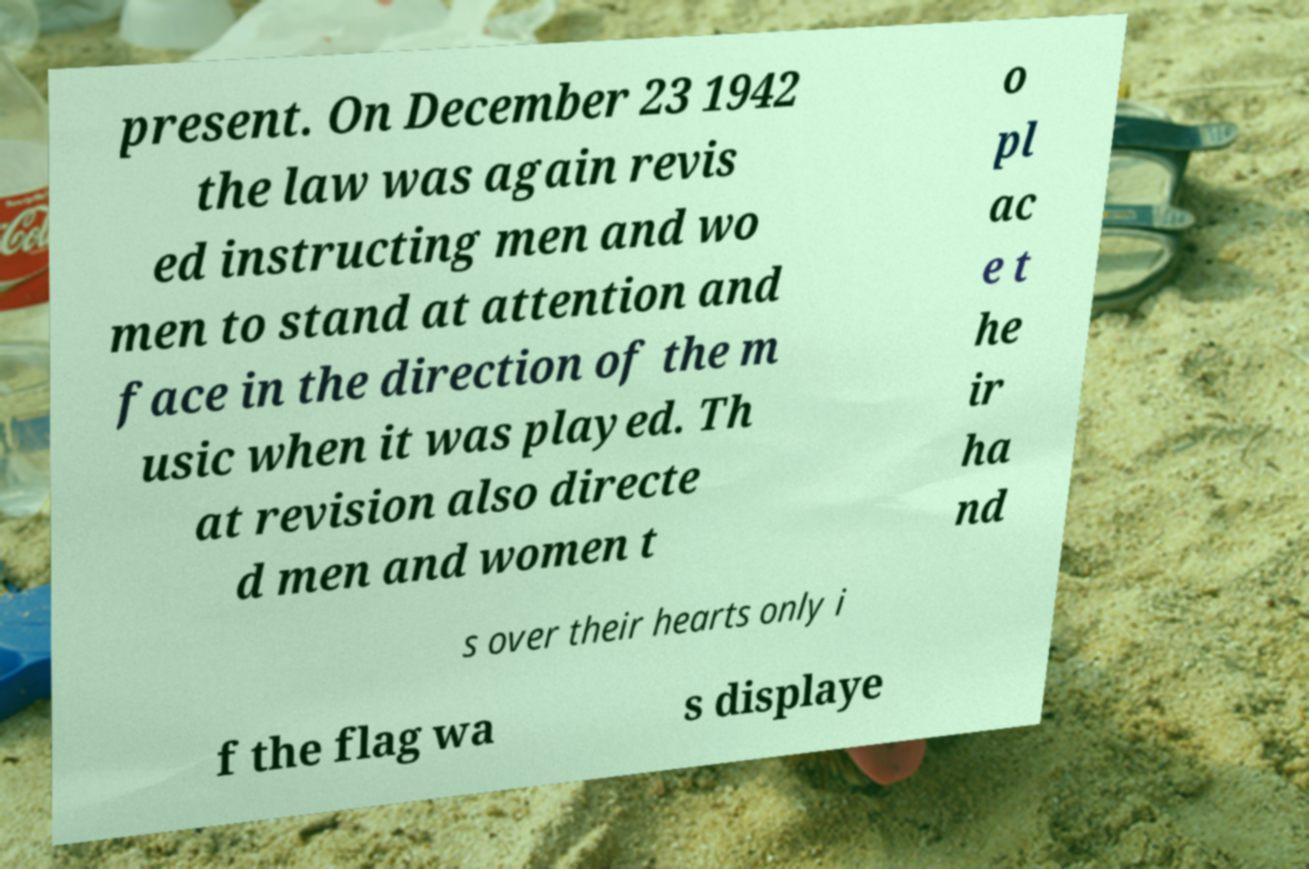I need the written content from this picture converted into text. Can you do that? present. On December 23 1942 the law was again revis ed instructing men and wo men to stand at attention and face in the direction of the m usic when it was played. Th at revision also directe d men and women t o pl ac e t he ir ha nd s over their hearts only i f the flag wa s displaye 